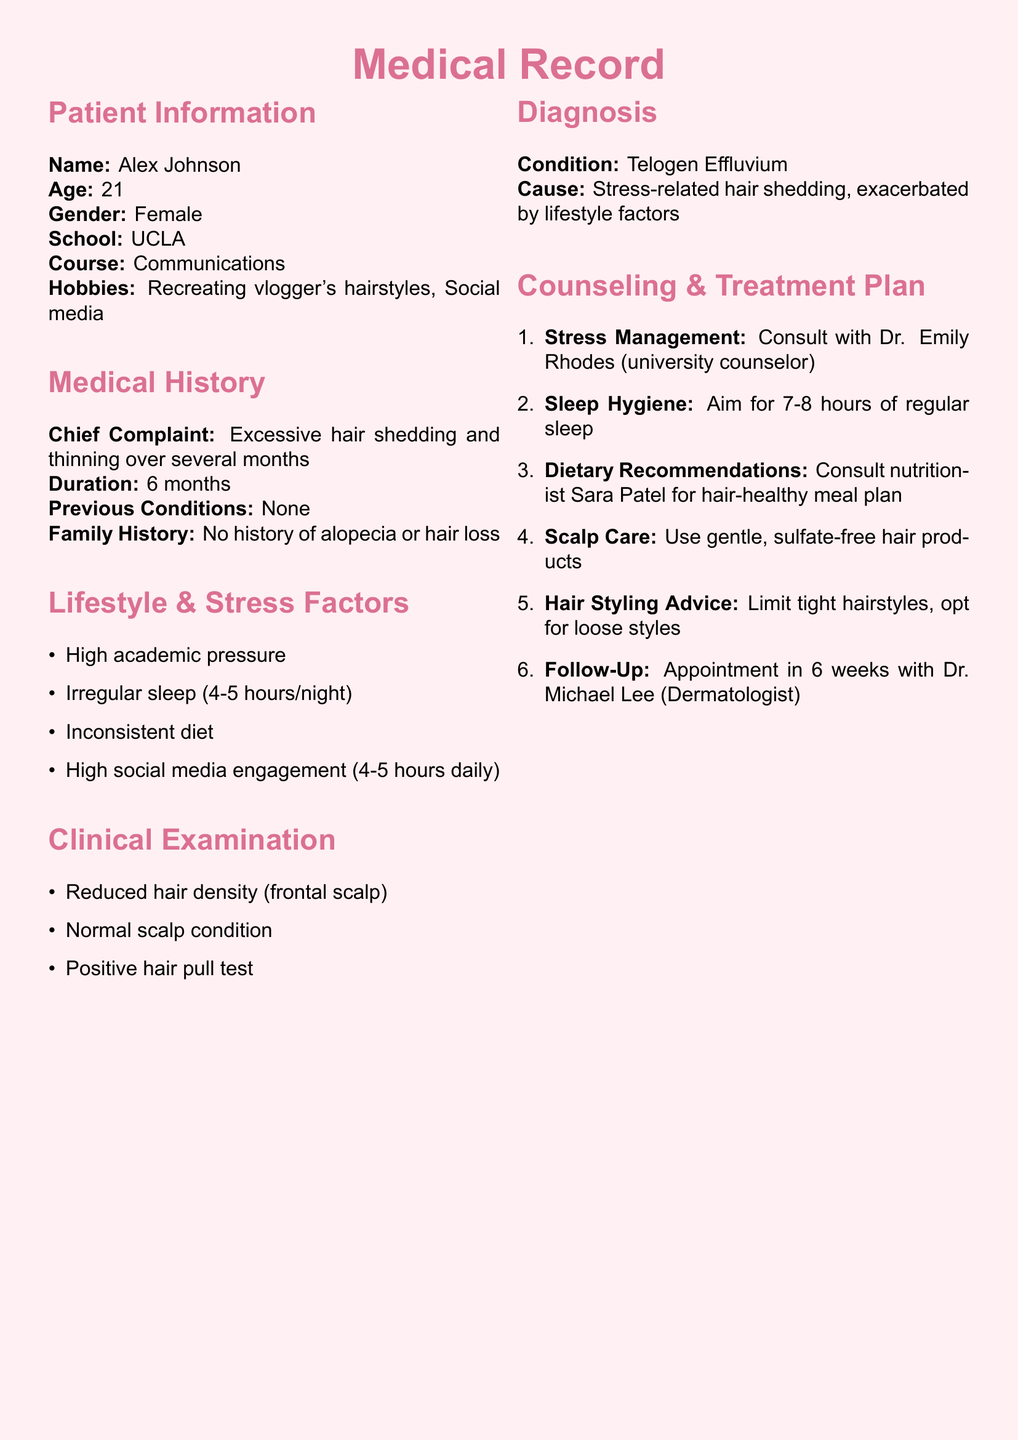What is the patient's name? The patient's name is listed in the Patient Information section of the document.
Answer: Alex Johnson What is the age of Alex Johnson? The age is provided in the Patient Information section.
Answer: 21 What is the chief complaint noted in the medical record? The chief complaint is detailed in the Medical History section.
Answer: Excessive hair shedding and thinning How long has the patient been experiencing hair loss? The duration of the hair loss is specified in the Medical History section.
Answer: 6 months What condition was diagnosed in the patient? The diagnosis is explicitly mentioned in the Diagnosis section of the document.
Answer: Telogen Effluvium Who is the university counselor for stress management? The counselor's name is mentioned in the Counseling & Treatment Plan section.
Answer: Dr. Emily Rhodes What dietary recommendation is given to the patient? The dietary recommendation is found in the Counseling & Treatment Plan section.
Answer: Consult nutritionist Sara Patel for hair-healthy meal plan How many hours of sleep is recommended for the patient? The suggested amount of sleep is stated in the Counseling & Treatment Plan section.
Answer: 7-8 hours What is the follow-up appointment duration after the first visit? The follow-up duration is mentioned in the Counseling & Treatment Plan section.
Answer: In 6 weeks 